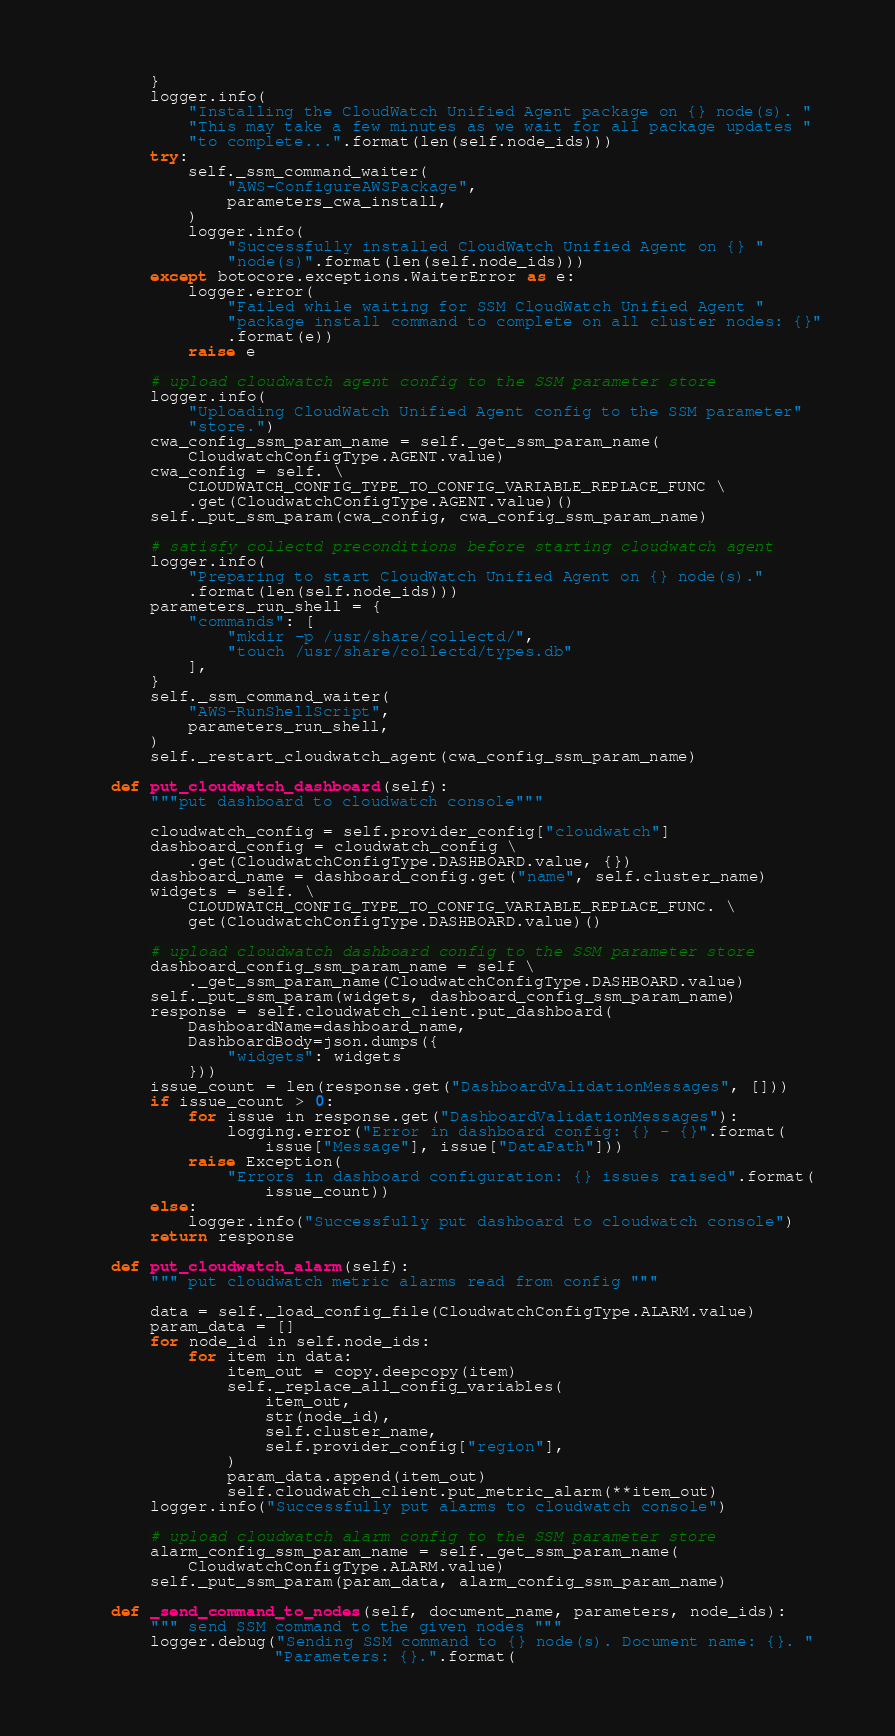Convert code to text. <code><loc_0><loc_0><loc_500><loc_500><_Python_>        }
        logger.info(
            "Installing the CloudWatch Unified Agent package on {} node(s). "
            "This may take a few minutes as we wait for all package updates "
            "to complete...".format(len(self.node_ids)))
        try:
            self._ssm_command_waiter(
                "AWS-ConfigureAWSPackage",
                parameters_cwa_install,
            )
            logger.info(
                "Successfully installed CloudWatch Unified Agent on {} "
                "node(s)".format(len(self.node_ids)))
        except botocore.exceptions.WaiterError as e:
            logger.error(
                "Failed while waiting for SSM CloudWatch Unified Agent "
                "package install command to complete on all cluster nodes: {}"
                .format(e))
            raise e

        # upload cloudwatch agent config to the SSM parameter store
        logger.info(
            "Uploading CloudWatch Unified Agent config to the SSM parameter"
            "store.")
        cwa_config_ssm_param_name = self._get_ssm_param_name(
            CloudwatchConfigType.AGENT.value)
        cwa_config = self. \
            CLOUDWATCH_CONFIG_TYPE_TO_CONFIG_VARIABLE_REPLACE_FUNC \
            .get(CloudwatchConfigType.AGENT.value)()
        self._put_ssm_param(cwa_config, cwa_config_ssm_param_name)

        # satisfy collectd preconditions before starting cloudwatch agent
        logger.info(
            "Preparing to start CloudWatch Unified Agent on {} node(s)."
            .format(len(self.node_ids)))
        parameters_run_shell = {
            "commands": [
                "mkdir -p /usr/share/collectd/",
                "touch /usr/share/collectd/types.db"
            ],
        }
        self._ssm_command_waiter(
            "AWS-RunShellScript",
            parameters_run_shell,
        )
        self._restart_cloudwatch_agent(cwa_config_ssm_param_name)

    def put_cloudwatch_dashboard(self):
        """put dashboard to cloudwatch console"""

        cloudwatch_config = self.provider_config["cloudwatch"]
        dashboard_config = cloudwatch_config \
            .get(CloudwatchConfigType.DASHBOARD.value, {})
        dashboard_name = dashboard_config.get("name", self.cluster_name)
        widgets = self. \
            CLOUDWATCH_CONFIG_TYPE_TO_CONFIG_VARIABLE_REPLACE_FUNC. \
            get(CloudwatchConfigType.DASHBOARD.value)()

        # upload cloudwatch dashboard config to the SSM parameter store
        dashboard_config_ssm_param_name = self \
            ._get_ssm_param_name(CloudwatchConfigType.DASHBOARD.value)
        self._put_ssm_param(widgets, dashboard_config_ssm_param_name)
        response = self.cloudwatch_client.put_dashboard(
            DashboardName=dashboard_name,
            DashboardBody=json.dumps({
                "widgets": widgets
            }))
        issue_count = len(response.get("DashboardValidationMessages", []))
        if issue_count > 0:
            for issue in response.get("DashboardValidationMessages"):
                logging.error("Error in dashboard config: {} - {}".format(
                    issue["Message"], issue["DataPath"]))
            raise Exception(
                "Errors in dashboard configuration: {} issues raised".format(
                    issue_count))
        else:
            logger.info("Successfully put dashboard to cloudwatch console")
        return response

    def put_cloudwatch_alarm(self):
        """ put cloudwatch metric alarms read from config """

        data = self._load_config_file(CloudwatchConfigType.ALARM.value)
        param_data = []
        for node_id in self.node_ids:
            for item in data:
                item_out = copy.deepcopy(item)
                self._replace_all_config_variables(
                    item_out,
                    str(node_id),
                    self.cluster_name,
                    self.provider_config["region"],
                )
                param_data.append(item_out)
                self.cloudwatch_client.put_metric_alarm(**item_out)
        logger.info("Successfully put alarms to cloudwatch console")

        # upload cloudwatch alarm config to the SSM parameter store
        alarm_config_ssm_param_name = self._get_ssm_param_name(
            CloudwatchConfigType.ALARM.value)
        self._put_ssm_param(param_data, alarm_config_ssm_param_name)

    def _send_command_to_nodes(self, document_name, parameters, node_ids):
        """ send SSM command to the given nodes """
        logger.debug("Sending SSM command to {} node(s). Document name: {}. "
                     "Parameters: {}.".format(</code> 